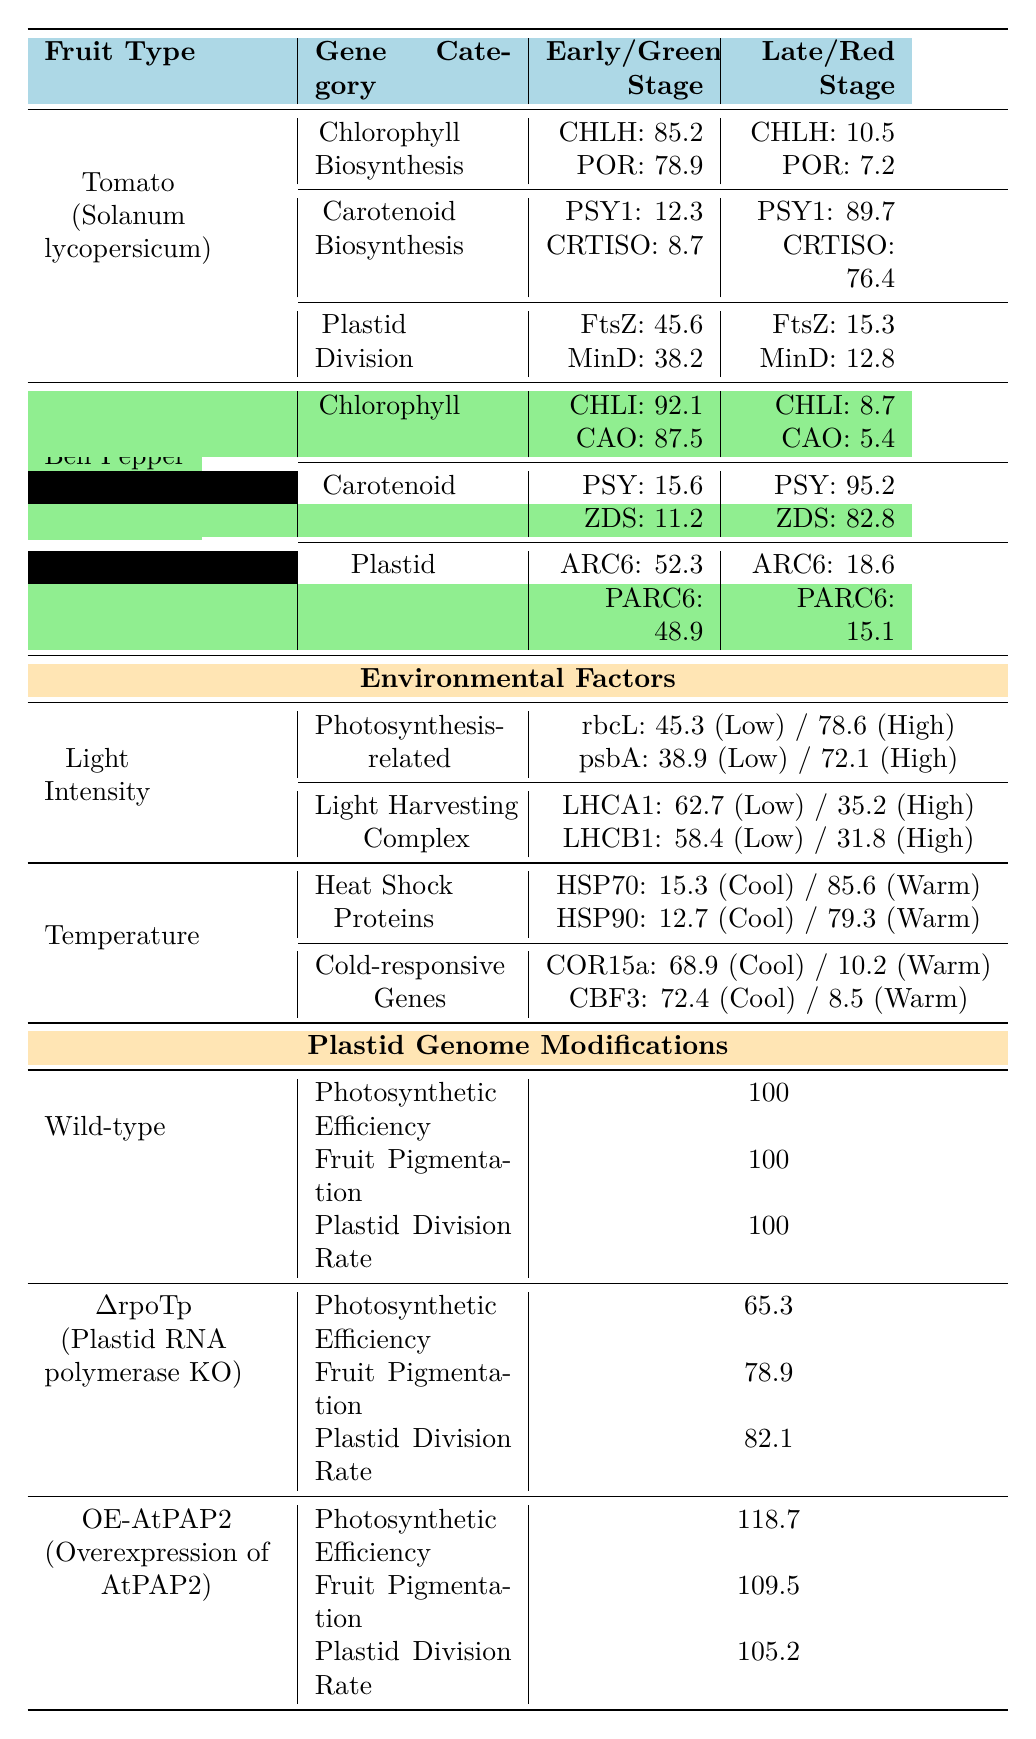What is the expression level of CHLH in the early ripening stage of tomato? The table shows that the expression level of CHLH (Magnesium chelatase) in the early ripening stage of tomato is 85.2.
Answer: 85.2 What are the values of PSY and ZDS in the red stage of bell pepper? In the red stage of bell pepper, the expression levels are PSY: 95.2 and ZDS: 82.8.
Answer: PSY: 95.2, ZDS: 82.8 Which gene exhibits the highest expression in the carotenoid biosynthesis category during the late ripening stage of tomato? The table indicates that PSY1 (Phytoene synthase 1) has the highest expression level of 89.7 during the late ripening stage of tomato.
Answer: PSY1 (89.7) What is the difference in expression levels of rbcL between low and high light conditions? The table indicates that rbcL has an expression level of 45.3 in low light and 78.6 in high light. The difference is calculated as 78.6 - 45.3 = 33.3.
Answer: 33.3 In which stage does the chlorophyll biosynthesis expression drop significantly for tomato, and what is the expression value? The expression of chlorophyll biosynthesis genes for tomato drops significantly from early (CHLH: 85.2, POR: 78.9) to late (CHLH: 10.5, POR: 7.2) stages. The values in the late stage are much lower, specifically CHLH: 10.5.
Answer: Late stage (CHLH: 10.5) True or False: The expression level of HSP90 decreases from cool (12.7) to warm temperatures (79.3). The table shows that HSP90 has an expression of 12.7 at cool temperatures and increases to 79.3 at warm temperatures, which means the statement is false.
Answer: False What is the total expression level for the plastid division genes in the early ripening stage of tomato? For the early ripening stage of tomato, FtsZ has a value of 45.6 and MinD has a value of 38.2. Summing these gives 45.6 + 38.2 = 83.8.
Answer: 83.8 Which fruit type has the highest expression of carotenoid biosynthesis genes in the late stage? The table shows that in the late stage, tomato has PSY1 at 89.7 and CRTISO at 76.4, while bell pepper has PSY at 95.2 and ZDS at 82.8. Therefore, bell pepper has the highest expression.
Answer: Bell pepper Compare the photosynthetic efficiency of wild-type and ΔrpoTp. What is the percentage difference? The wild-type has a photosynthetic efficiency of 100, while ΔrpoTp has 65.3. The percentage difference is ((100 - 65.3) / 100) * 100 = 34.7%.
Answer: 34.7% What is the average expression level of light harvesting complex genes in low light conditions? The expression values for LHCA1 and LHCB1 in low light are 62.7 and 58.4, respectively. The average is (62.7 + 58.4) / 2 = 60.55.
Answer: 60.55 Which plastid genome modification results in the highest fruit pigmentation? The OE-AtPAP2 modification results in the highest fruit pigmentation with a value of 109.5, compared to wild-type (100) and ΔrpoTp (78.9).
Answer: OE-AtPAP2 